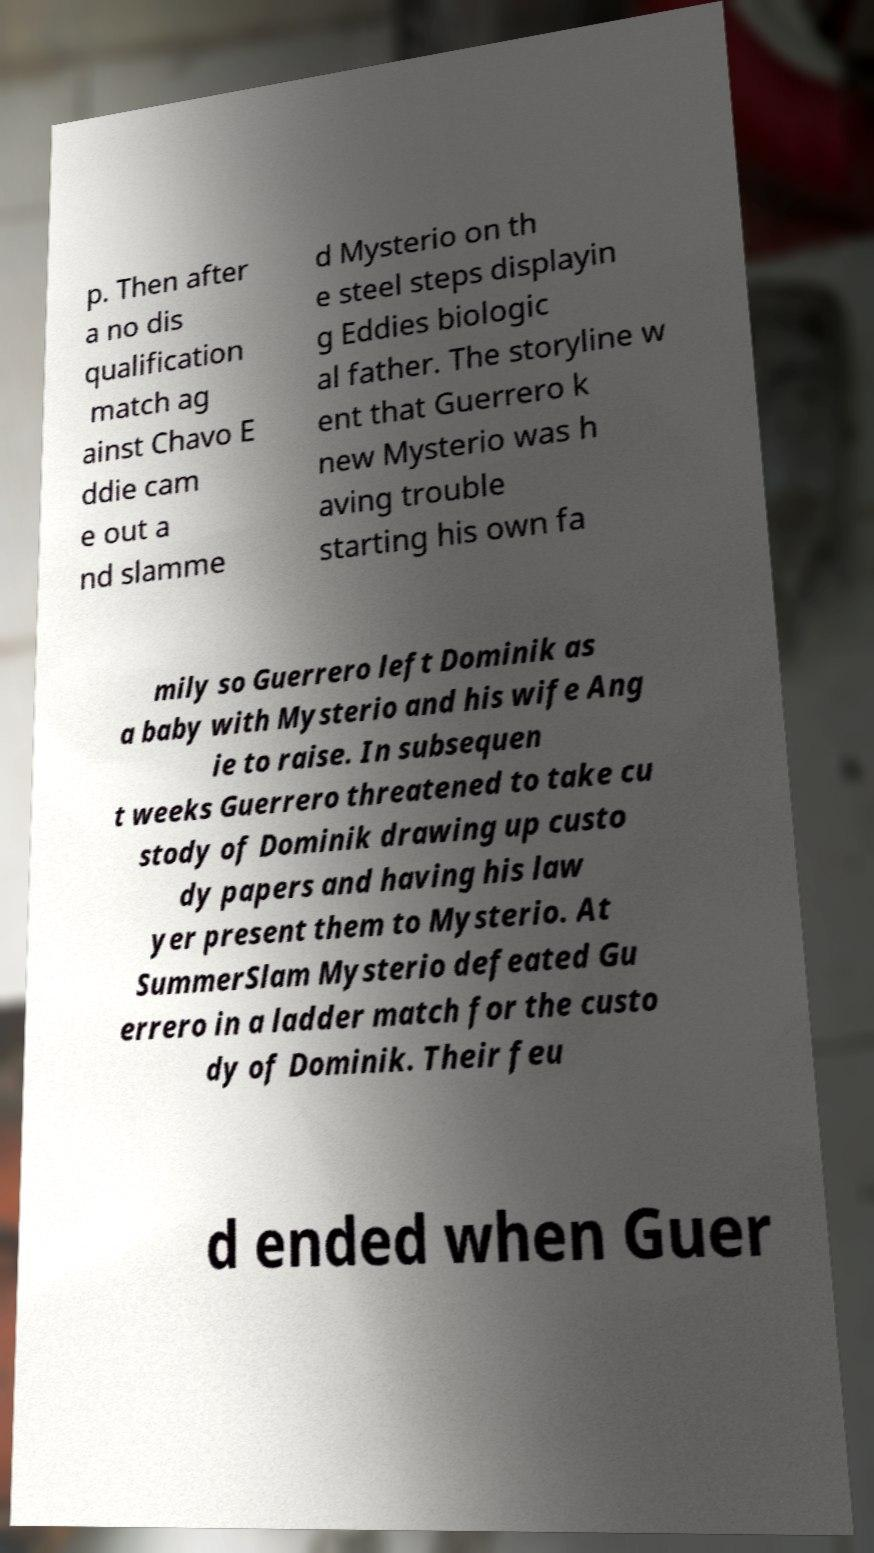Can you read and provide the text displayed in the image?This photo seems to have some interesting text. Can you extract and type it out for me? p. Then after a no dis qualification match ag ainst Chavo E ddie cam e out a nd slamme d Mysterio on th e steel steps displayin g Eddies biologic al father. The storyline w ent that Guerrero k new Mysterio was h aving trouble starting his own fa mily so Guerrero left Dominik as a baby with Mysterio and his wife Ang ie to raise. In subsequen t weeks Guerrero threatened to take cu stody of Dominik drawing up custo dy papers and having his law yer present them to Mysterio. At SummerSlam Mysterio defeated Gu errero in a ladder match for the custo dy of Dominik. Their feu d ended when Guer 